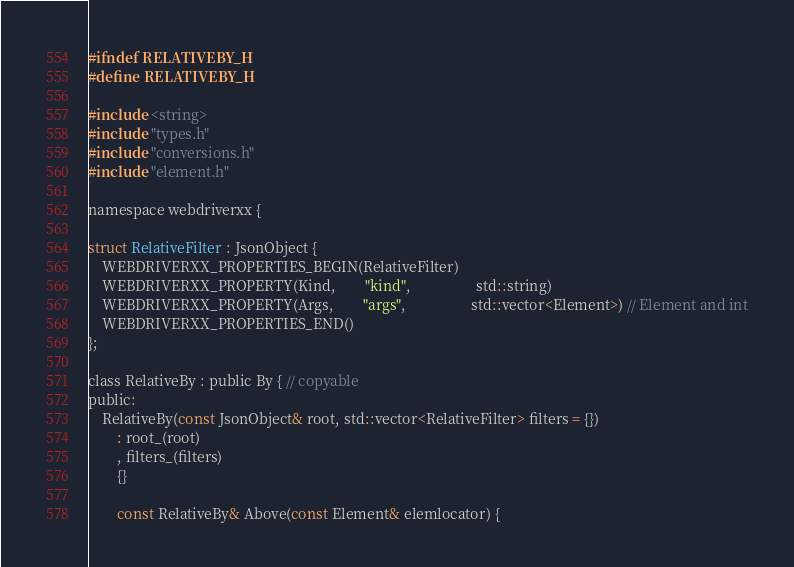Convert code to text. <code><loc_0><loc_0><loc_500><loc_500><_C_>#ifndef RELATIVEBY_H
#define RELATIVEBY_H

#include <string>
#include "types.h"
#include "conversions.h"
#include "element.h"

namespace webdriverxx {

struct RelativeFilter : JsonObject {
    WEBDRIVERXX_PROPERTIES_BEGIN(RelativeFilter)
    WEBDRIVERXX_PROPERTY(Kind,        "kind",                  std::string)
    WEBDRIVERXX_PROPERTY(Args,        "args",                  std::vector<Element>) // Element and int
    WEBDRIVERXX_PROPERTIES_END()
};

class RelativeBy : public By { // copyable
public:
	RelativeBy(const JsonObject& root, std::vector<RelativeFilter> filters = {})
		: root_(root)
		, filters_(filters)
		{}

        const RelativeBy& Above(const Element& elemlocator) {</code> 